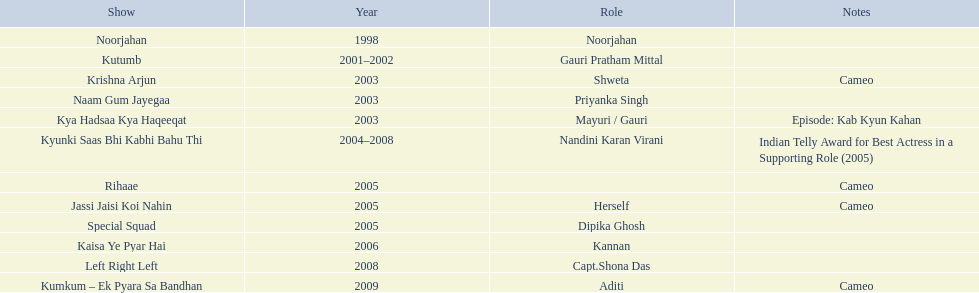The shows with at most 1 cameo Krishna Arjun, Rihaae, Jassi Jaisi Koi Nahin, Kumkum - Ek Pyara Sa Bandhan. 